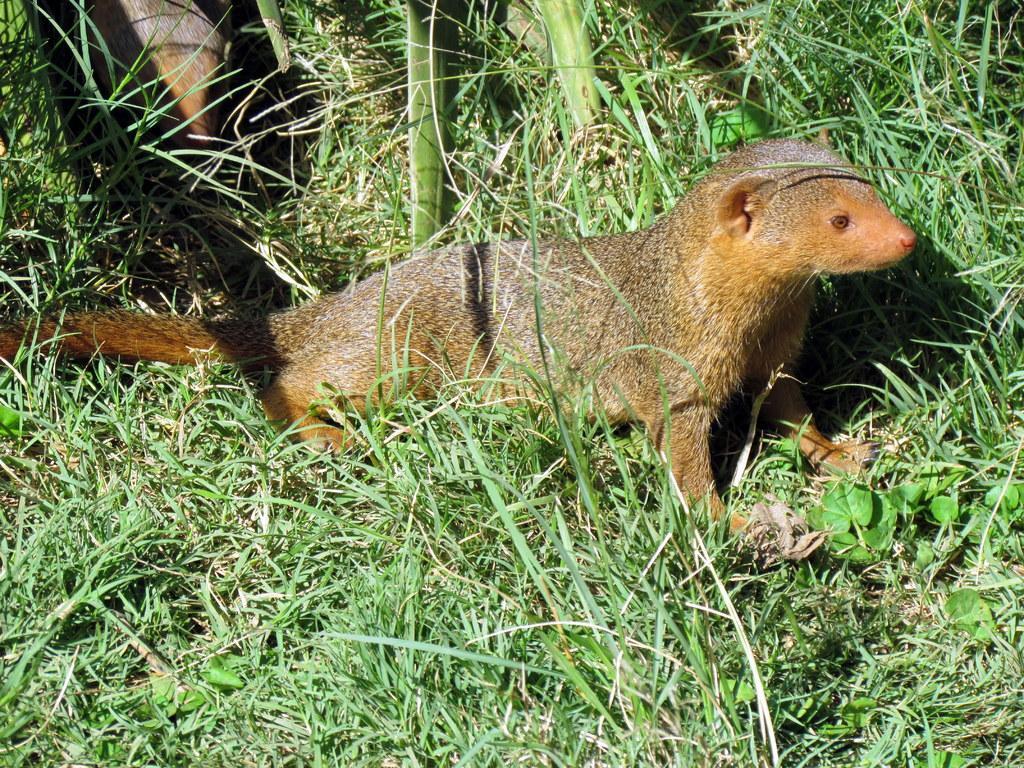Could you give a brief overview of what you see in this image? On the ground there is grass and small plants. On that there are two animals. 